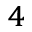<formula> <loc_0><loc_0><loc_500><loc_500>^ { 4 }</formula> 